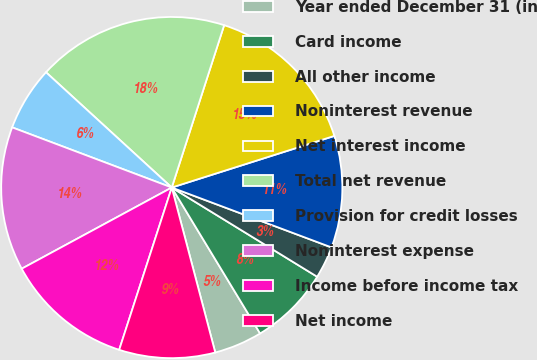Convert chart to OTSL. <chart><loc_0><loc_0><loc_500><loc_500><pie_chart><fcel>Year ended December 31 (in<fcel>Card income<fcel>All other income<fcel>Noninterest revenue<fcel>Net interest income<fcel>Total net revenue<fcel>Provision for credit losses<fcel>Noninterest expense<fcel>Income before income tax<fcel>Net income<nl><fcel>4.56%<fcel>7.58%<fcel>3.05%<fcel>10.6%<fcel>15.14%<fcel>18.16%<fcel>6.07%<fcel>13.63%<fcel>12.12%<fcel>9.09%<nl></chart> 